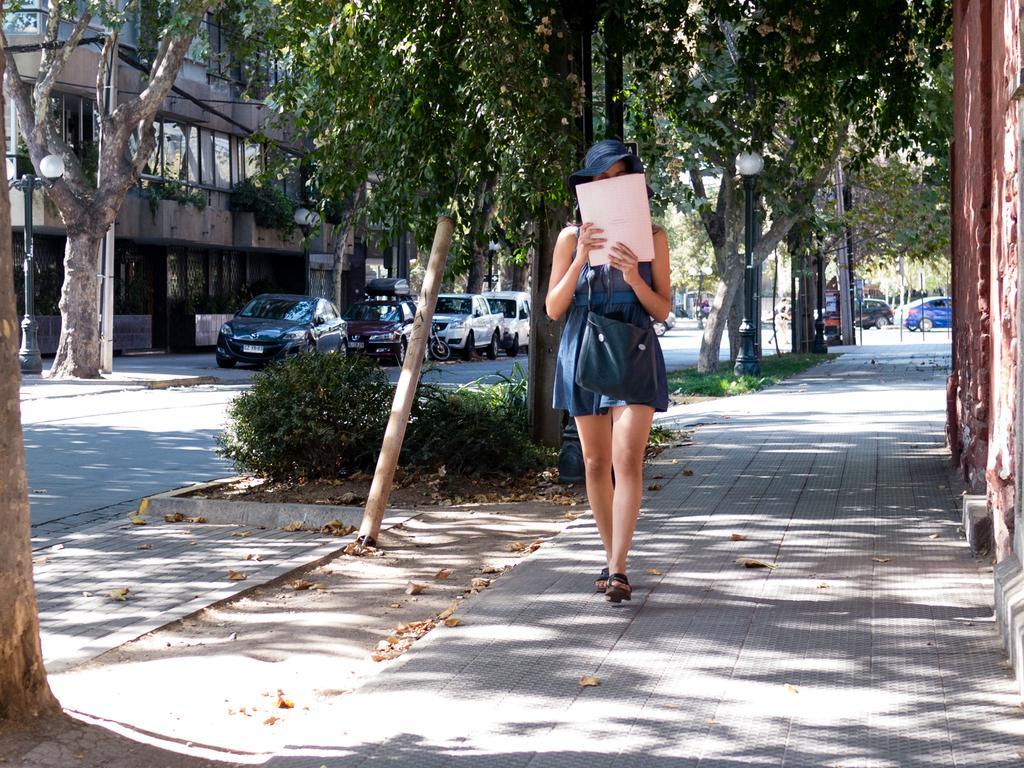Describe this image in one or two sentences. In this image we can see a woman walking on the platform. Here we can see plants, grass, vehicles, road, poles, and trees. In the background we can see a building. 